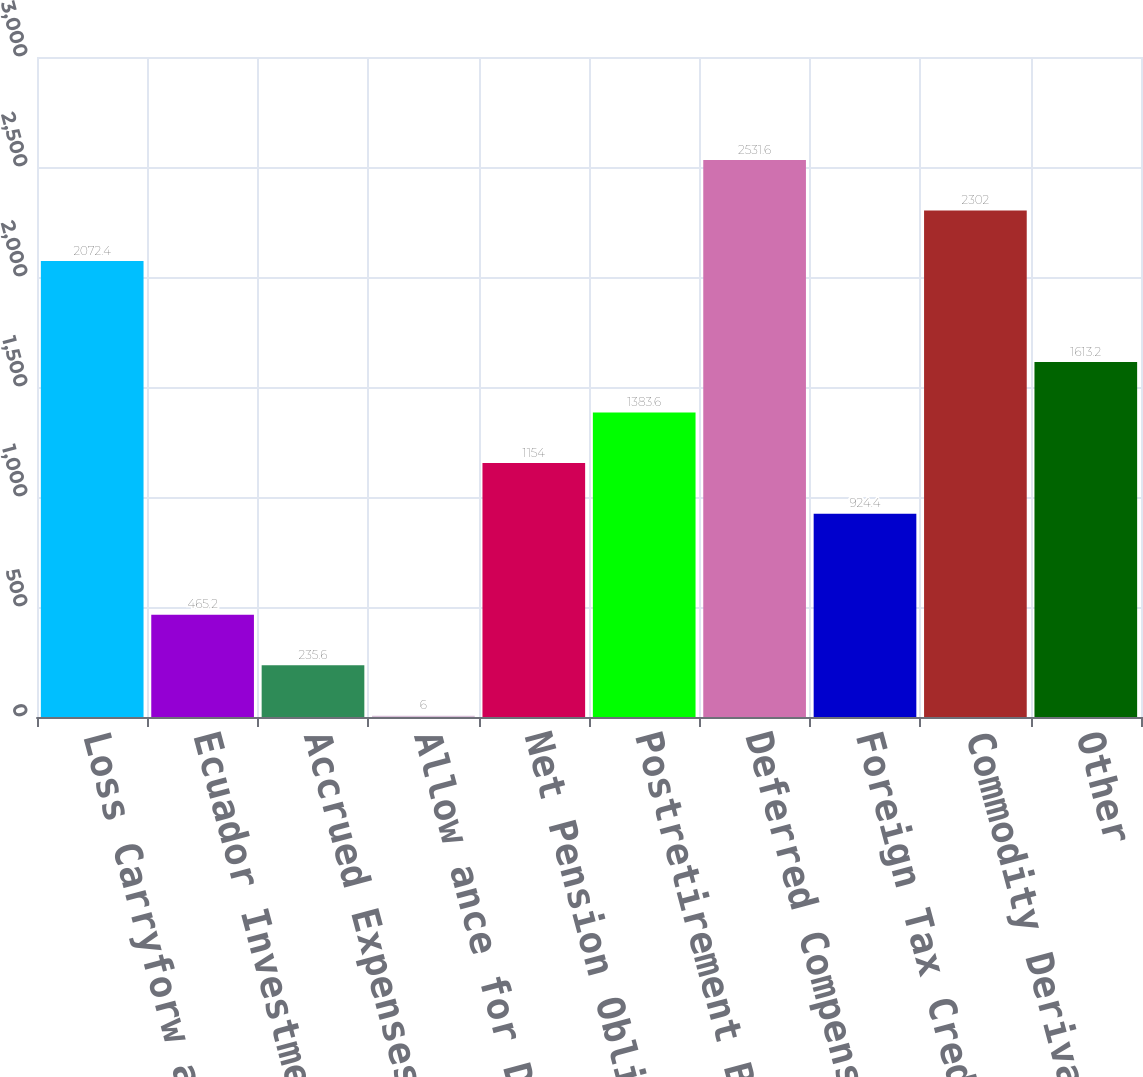<chart> <loc_0><loc_0><loc_500><loc_500><bar_chart><fcel>Loss Carryforw ards<fcel>Ecuador Investment<fcel>Accrued Expenses<fcel>Allow ance for Doubtful<fcel>Net Pension Obligation<fcel>Postretirement Benefits<fcel>Deferred Compensation<fcel>Foreign Tax Credits<fcel>Commodity Derivative Assets<fcel>Other<nl><fcel>2072.4<fcel>465.2<fcel>235.6<fcel>6<fcel>1154<fcel>1383.6<fcel>2531.6<fcel>924.4<fcel>2302<fcel>1613.2<nl></chart> 